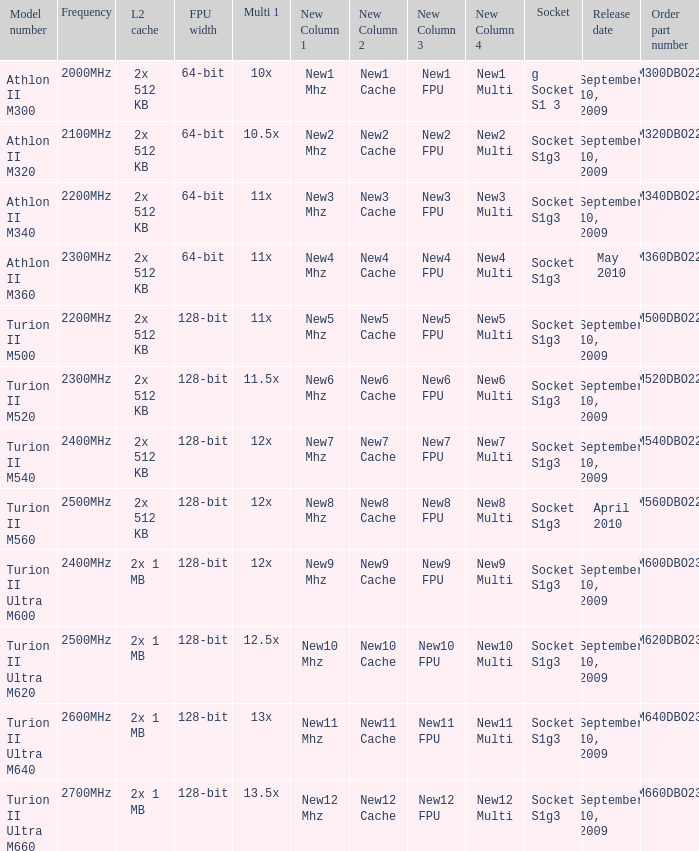What is the frequency of the tmm500dbo22gq order part number? 2200MHz. I'm looking to parse the entire table for insights. Could you assist me with that? {'header': ['Model number', 'Frequency', 'L2 cache', 'FPU width', 'Multi 1', 'New Column 1', 'New Column 2', 'New Column 3', 'New Column 4', 'Socket', 'Release date', 'Order part number'], 'rows': [['Athlon II M300', '2000MHz', '2x 512 KB', '64-bit', '10x', 'New1 Mhz', 'New1 Cache', 'New1 FPU', 'New1 Multi ', 'g Socket S1 3', 'September 10, 2009', 'AMM300DBO22GQ'], ['Athlon II M320', '2100MHz', '2x 512 KB', '64-bit', '10.5x', 'New2 Mhz', 'New2 Cache', 'New2 FPU', 'New2 Multi', 'Socket S1g3', 'September 10, 2009', 'AMM320DBO22GQ'], ['Athlon II M340', '2200MHz', '2x 512 KB', '64-bit', '11x', 'New3 Mhz', 'New3 Cache', 'New3 FPU', 'New3 Multi', 'Socket S1g3', 'September 10, 2009', 'AMM340DBO22GQ'], ['Athlon II M360', '2300MHz', '2x 512 KB', '64-bit', '11x', 'New4 Mhz', 'New4 Cache', 'New4 FPU', 'New4 Multi', 'Socket S1g3', 'May 2010', 'AMM360DBO22GQ'], ['Turion II M500', '2200MHz', '2x 512 KB', '128-bit', '11x', 'New5 Mhz', 'New5 Cache', 'New5 FPU', 'New5 Multi', 'Socket S1g3', 'September 10, 2009', 'TMM500DBO22GQ'], ['Turion II M520', '2300MHz', '2x 512 KB', '128-bit', '11.5x', 'New6 Mhz', 'New6 Cache', 'New6 FPU', 'New6 Multi', 'Socket S1g3', 'September 10, 2009', 'TMM520DBO22GQ'], ['Turion II M540', '2400MHz', '2x 512 KB', '128-bit', '12x', 'New7 Mhz', 'New7 Cache', 'New7 FPU', 'New7 Multi', 'Socket S1g3', 'September 10, 2009', 'TMM540DBO22GQ'], ['Turion II M560', '2500MHz', '2x 512 KB', '128-bit', '12x', 'New8 Mhz', 'New8 Cache', 'New8 FPU', 'New8 Multi', 'Socket S1g3', 'April 2010', 'TMM560DBO22GQ'], ['Turion II Ultra M600', '2400MHz', '2x 1 MB', '128-bit', '12x', 'New9 Mhz', 'New9 Cache', 'New9 FPU', 'New9 Multi', 'Socket S1g3', 'September 10, 2009', 'TMM600DBO23GQ'], ['Turion II Ultra M620', '2500MHz', '2x 1 MB', '128-bit', '12.5x', 'New10 Mhz', 'New10 Cache', 'New10 FPU', 'New10 Multi ', 'Socket S1g3', 'September 10, 2009', 'TMM620DBO23GQ'], ['Turion II Ultra M640', '2600MHz', '2x 1 MB', '128-bit', '13x', 'New11 Mhz', 'New11 Cache', 'New11 FPU', 'New11 Multi', 'Socket S1g3', 'September 10, 2009', 'TMM640DBO23GQ'], ['Turion II Ultra M660', '2700MHz', '2x 1 MB', '128-bit', '13.5x', 'New12 Mhz', 'New12 Cache', 'New12 FPU', 'New12 Multi', 'Socket S1g3', 'September 10, 2009', 'TMM660DBO23GQ']]} 